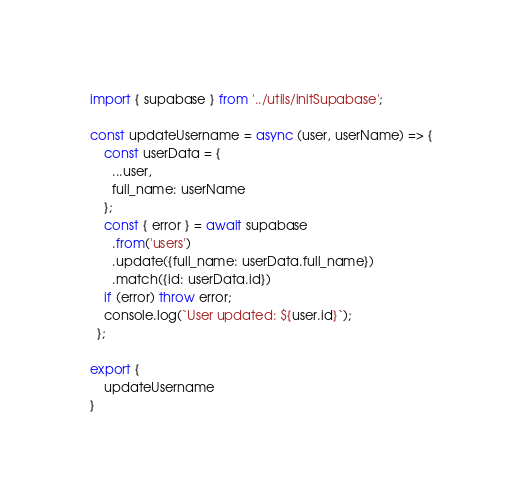<code> <loc_0><loc_0><loc_500><loc_500><_JavaScript_>import { supabase } from '../utils/initSupabase';

const updateUsername = async (user, userName) => {
    const userData = {
      ...user,
      full_name: userName
    };
    const { error } = await supabase
      .from('users')
      .update({full_name: userData.full_name})
      .match({id: userData.id})
    if (error) throw error;
    console.log(`User updated: ${user.id}`);
  };

export {
    updateUsername
}</code> 